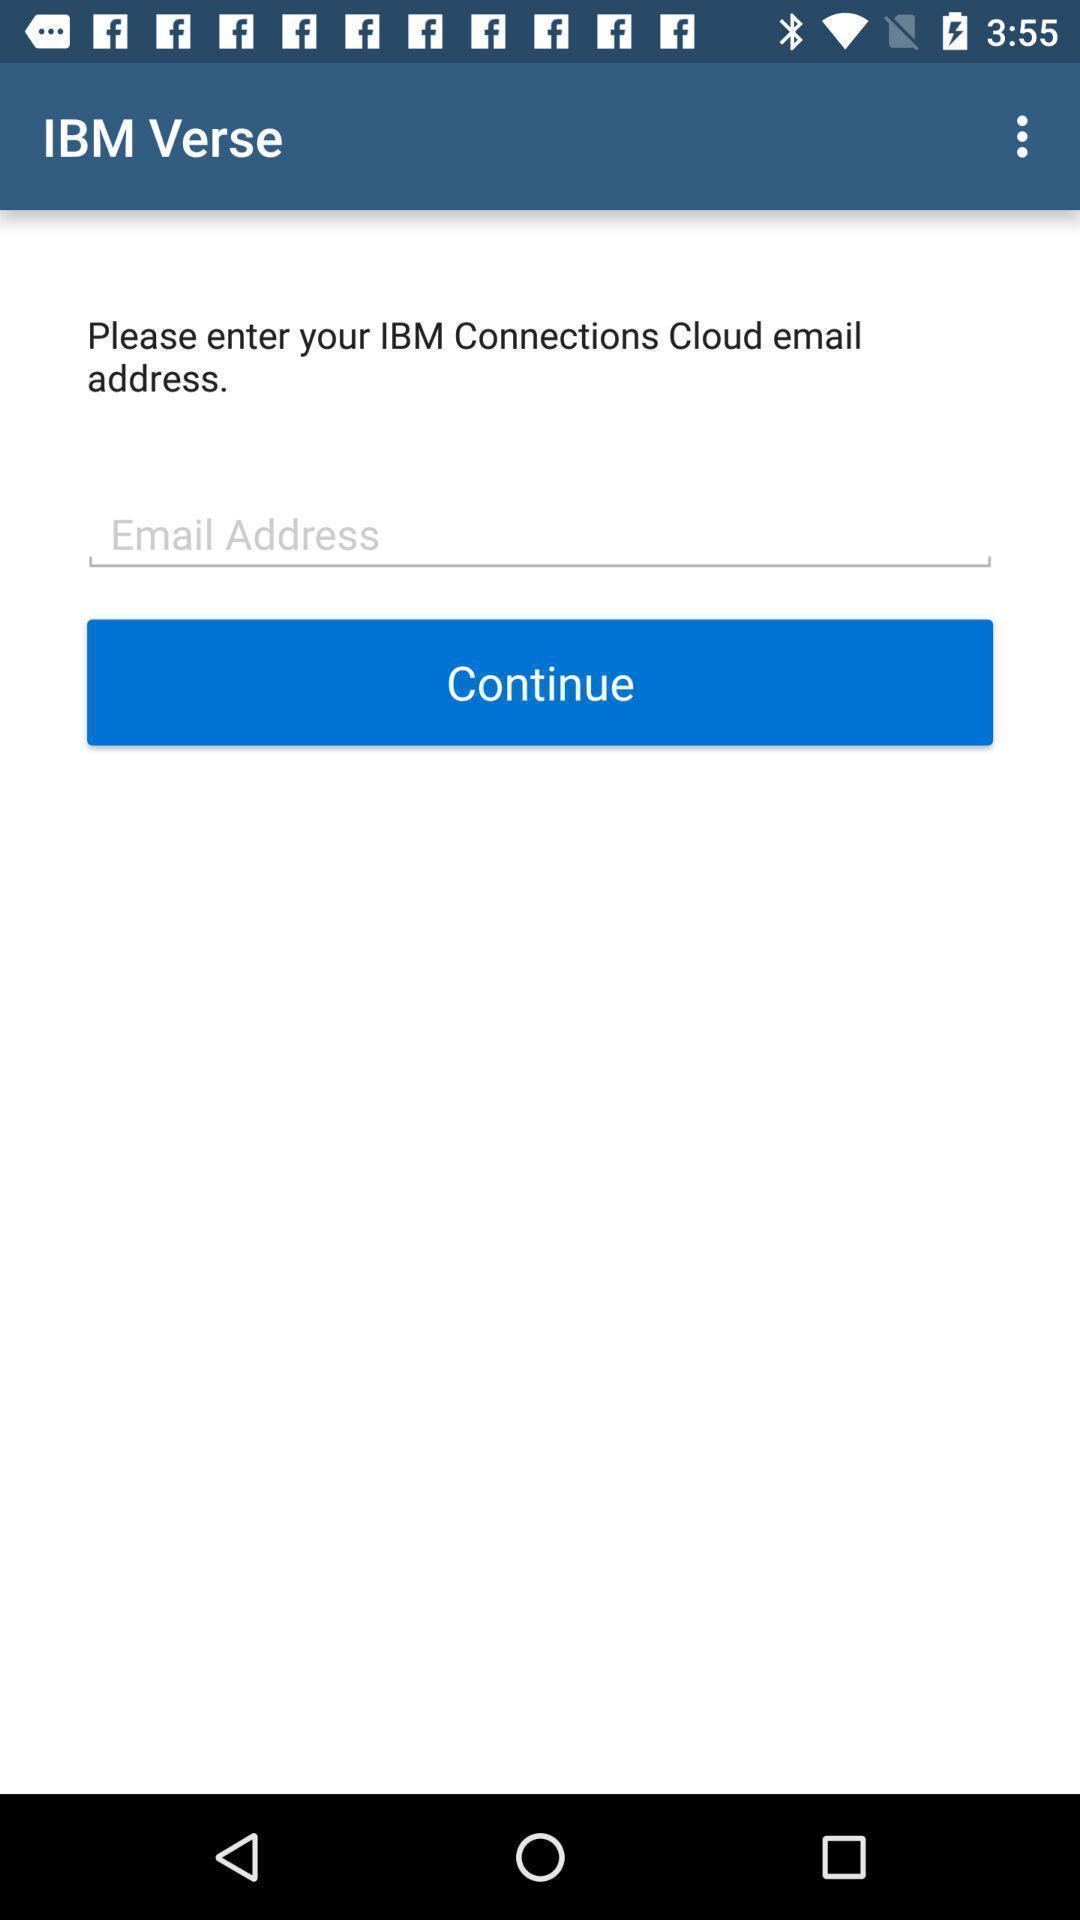Please provide a description for this image. Page showing option like continue. 